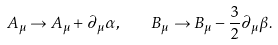Convert formula to latex. <formula><loc_0><loc_0><loc_500><loc_500>A _ { \mu } \rightarrow A _ { \mu } + \partial _ { \mu } \alpha , \quad B _ { \mu } \rightarrow B _ { \mu } - \frac { 3 } { 2 } \partial _ { \mu } \beta .</formula> 